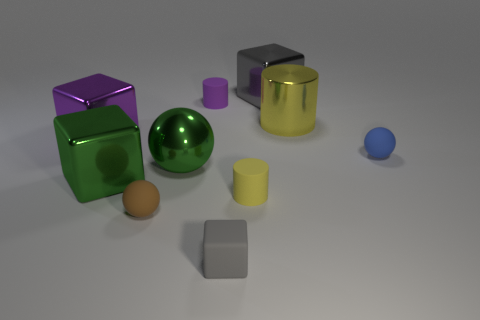There is a big green object to the right of the big green cube; does it have the same shape as the yellow object in front of the big purple metallic thing?
Offer a terse response. No. How many tiny balls are there?
Provide a short and direct response. 2. What is the shape of the small yellow object that is made of the same material as the tiny blue object?
Offer a terse response. Cylinder. Is there anything else of the same color as the metal cylinder?
Provide a short and direct response. Yes. There is a tiny matte block; is it the same color as the rubber cylinder in front of the big purple thing?
Your answer should be compact. No. Are there fewer purple rubber cylinders in front of the tiny yellow object than big green objects?
Your answer should be compact. Yes. What material is the small cylinder that is in front of the purple matte cylinder?
Offer a terse response. Rubber. How many other things are the same size as the purple rubber cylinder?
Offer a terse response. 4. There is a green metallic ball; is its size the same as the sphere that is to the right of the green sphere?
Offer a terse response. No. The purple rubber object to the left of the gray block that is in front of the tiny object that is left of the tiny purple cylinder is what shape?
Offer a terse response. Cylinder. 